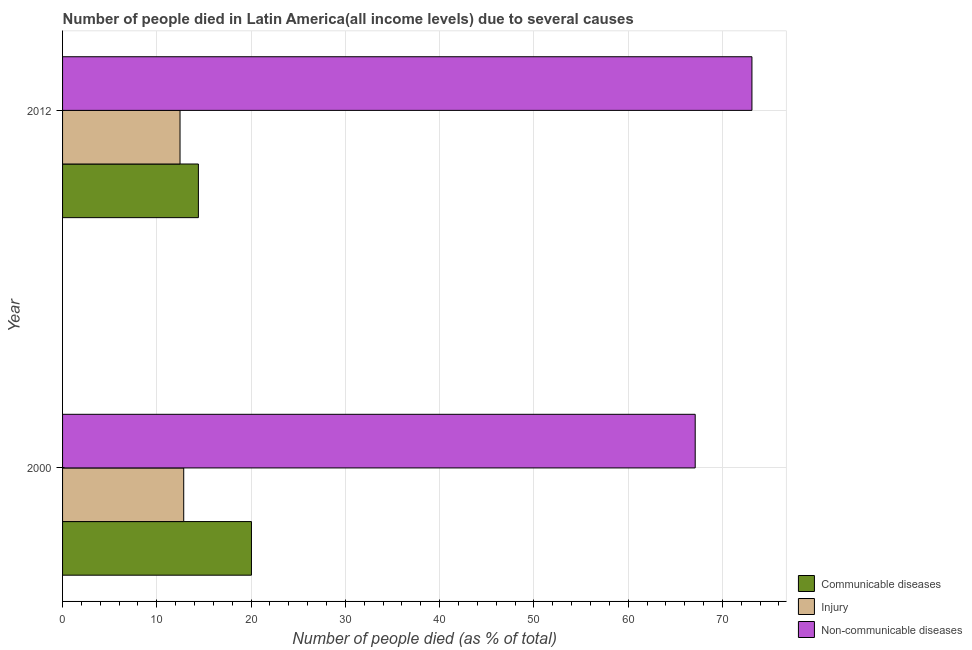How many groups of bars are there?
Ensure brevity in your answer.  2. Are the number of bars per tick equal to the number of legend labels?
Provide a short and direct response. Yes. Are the number of bars on each tick of the Y-axis equal?
Ensure brevity in your answer.  Yes. How many bars are there on the 1st tick from the top?
Provide a short and direct response. 3. How many bars are there on the 2nd tick from the bottom?
Offer a very short reply. 3. In how many cases, is the number of bars for a given year not equal to the number of legend labels?
Provide a succinct answer. 0. What is the number of people who died of injury in 2000?
Your response must be concise. 12.85. Across all years, what is the maximum number of people who died of injury?
Provide a succinct answer. 12.85. Across all years, what is the minimum number of people who died of communicable diseases?
Keep it short and to the point. 14.41. What is the total number of people who died of injury in the graph?
Give a very brief answer. 25.31. What is the difference between the number of people who died of communicable diseases in 2000 and that in 2012?
Offer a terse response. 5.63. What is the difference between the number of people who died of communicable diseases in 2000 and the number of people who dies of non-communicable diseases in 2012?
Ensure brevity in your answer.  -53.09. What is the average number of people who died of injury per year?
Give a very brief answer. 12.66. In the year 2012, what is the difference between the number of people who died of injury and number of people who died of communicable diseases?
Your answer should be very brief. -1.95. In how many years, is the number of people who dies of non-communicable diseases greater than 42 %?
Ensure brevity in your answer.  2. What is the ratio of the number of people who died of injury in 2000 to that in 2012?
Your response must be concise. 1.03. Is the difference between the number of people who died of communicable diseases in 2000 and 2012 greater than the difference between the number of people who dies of non-communicable diseases in 2000 and 2012?
Offer a terse response. Yes. In how many years, is the number of people who dies of non-communicable diseases greater than the average number of people who dies of non-communicable diseases taken over all years?
Give a very brief answer. 1. What does the 2nd bar from the top in 2012 represents?
Keep it short and to the point. Injury. What does the 3rd bar from the bottom in 2000 represents?
Keep it short and to the point. Non-communicable diseases. Are the values on the major ticks of X-axis written in scientific E-notation?
Give a very brief answer. No. Does the graph contain any zero values?
Make the answer very short. No. Does the graph contain grids?
Ensure brevity in your answer.  Yes. How many legend labels are there?
Your answer should be very brief. 3. How are the legend labels stacked?
Ensure brevity in your answer.  Vertical. What is the title of the graph?
Provide a succinct answer. Number of people died in Latin America(all income levels) due to several causes. Does "Textiles and clothing" appear as one of the legend labels in the graph?
Ensure brevity in your answer.  No. What is the label or title of the X-axis?
Your answer should be compact. Number of people died (as % of total). What is the label or title of the Y-axis?
Ensure brevity in your answer.  Year. What is the Number of people died (as % of total) in Communicable diseases in 2000?
Ensure brevity in your answer.  20.04. What is the Number of people died (as % of total) of Injury in 2000?
Your answer should be compact. 12.85. What is the Number of people died (as % of total) of Non-communicable diseases in 2000?
Provide a succinct answer. 67.11. What is the Number of people died (as % of total) in Communicable diseases in 2012?
Ensure brevity in your answer.  14.41. What is the Number of people died (as % of total) in Injury in 2012?
Offer a very short reply. 12.46. What is the Number of people died (as % of total) in Non-communicable diseases in 2012?
Ensure brevity in your answer.  73.13. Across all years, what is the maximum Number of people died (as % of total) of Communicable diseases?
Give a very brief answer. 20.04. Across all years, what is the maximum Number of people died (as % of total) in Injury?
Offer a terse response. 12.85. Across all years, what is the maximum Number of people died (as % of total) of Non-communicable diseases?
Offer a very short reply. 73.13. Across all years, what is the minimum Number of people died (as % of total) of Communicable diseases?
Keep it short and to the point. 14.41. Across all years, what is the minimum Number of people died (as % of total) of Injury?
Make the answer very short. 12.46. Across all years, what is the minimum Number of people died (as % of total) in Non-communicable diseases?
Offer a terse response. 67.11. What is the total Number of people died (as % of total) in Communicable diseases in the graph?
Your answer should be very brief. 34.45. What is the total Number of people died (as % of total) in Injury in the graph?
Offer a very short reply. 25.31. What is the total Number of people died (as % of total) in Non-communicable diseases in the graph?
Ensure brevity in your answer.  140.24. What is the difference between the Number of people died (as % of total) in Communicable diseases in 2000 and that in 2012?
Your answer should be very brief. 5.63. What is the difference between the Number of people died (as % of total) of Injury in 2000 and that in 2012?
Your answer should be compact. 0.39. What is the difference between the Number of people died (as % of total) in Non-communicable diseases in 2000 and that in 2012?
Ensure brevity in your answer.  -6.02. What is the difference between the Number of people died (as % of total) in Communicable diseases in 2000 and the Number of people died (as % of total) in Injury in 2012?
Your response must be concise. 7.58. What is the difference between the Number of people died (as % of total) in Communicable diseases in 2000 and the Number of people died (as % of total) in Non-communicable diseases in 2012?
Offer a terse response. -53.09. What is the difference between the Number of people died (as % of total) in Injury in 2000 and the Number of people died (as % of total) in Non-communicable diseases in 2012?
Your answer should be very brief. -60.28. What is the average Number of people died (as % of total) in Communicable diseases per year?
Give a very brief answer. 17.22. What is the average Number of people died (as % of total) in Injury per year?
Ensure brevity in your answer.  12.66. What is the average Number of people died (as % of total) of Non-communicable diseases per year?
Ensure brevity in your answer.  70.12. In the year 2000, what is the difference between the Number of people died (as % of total) of Communicable diseases and Number of people died (as % of total) of Injury?
Your response must be concise. 7.18. In the year 2000, what is the difference between the Number of people died (as % of total) in Communicable diseases and Number of people died (as % of total) in Non-communicable diseases?
Your response must be concise. -47.07. In the year 2000, what is the difference between the Number of people died (as % of total) of Injury and Number of people died (as % of total) of Non-communicable diseases?
Your response must be concise. -54.26. In the year 2012, what is the difference between the Number of people died (as % of total) in Communicable diseases and Number of people died (as % of total) in Injury?
Make the answer very short. 1.95. In the year 2012, what is the difference between the Number of people died (as % of total) of Communicable diseases and Number of people died (as % of total) of Non-communicable diseases?
Keep it short and to the point. -58.72. In the year 2012, what is the difference between the Number of people died (as % of total) of Injury and Number of people died (as % of total) of Non-communicable diseases?
Ensure brevity in your answer.  -60.67. What is the ratio of the Number of people died (as % of total) in Communicable diseases in 2000 to that in 2012?
Your answer should be compact. 1.39. What is the ratio of the Number of people died (as % of total) in Injury in 2000 to that in 2012?
Your response must be concise. 1.03. What is the ratio of the Number of people died (as % of total) in Non-communicable diseases in 2000 to that in 2012?
Your answer should be very brief. 0.92. What is the difference between the highest and the second highest Number of people died (as % of total) in Communicable diseases?
Provide a succinct answer. 5.63. What is the difference between the highest and the second highest Number of people died (as % of total) of Injury?
Provide a short and direct response. 0.39. What is the difference between the highest and the second highest Number of people died (as % of total) in Non-communicable diseases?
Ensure brevity in your answer.  6.02. What is the difference between the highest and the lowest Number of people died (as % of total) of Communicable diseases?
Make the answer very short. 5.63. What is the difference between the highest and the lowest Number of people died (as % of total) in Injury?
Offer a terse response. 0.39. What is the difference between the highest and the lowest Number of people died (as % of total) of Non-communicable diseases?
Offer a very short reply. 6.02. 